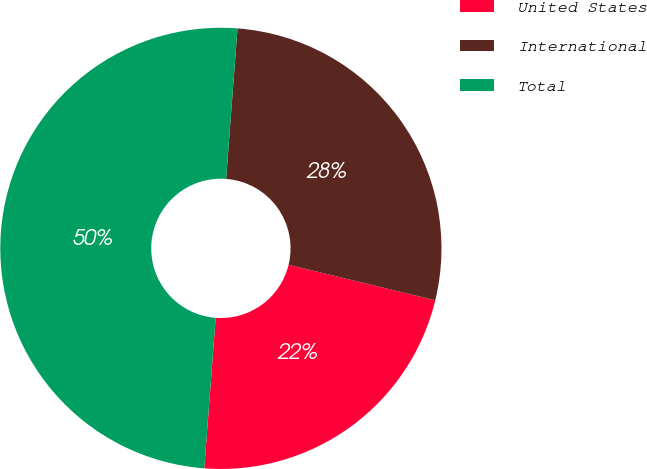<chart> <loc_0><loc_0><loc_500><loc_500><pie_chart><fcel>United States<fcel>International<fcel>Total<nl><fcel>22.42%<fcel>27.58%<fcel>50.0%<nl></chart> 